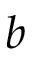Convert formula to latex. <formula><loc_0><loc_0><loc_500><loc_500>b</formula> 